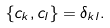<formula> <loc_0><loc_0><loc_500><loc_500>\{ c _ { k } , c _ { l } \} = \delta _ { k l } .</formula> 